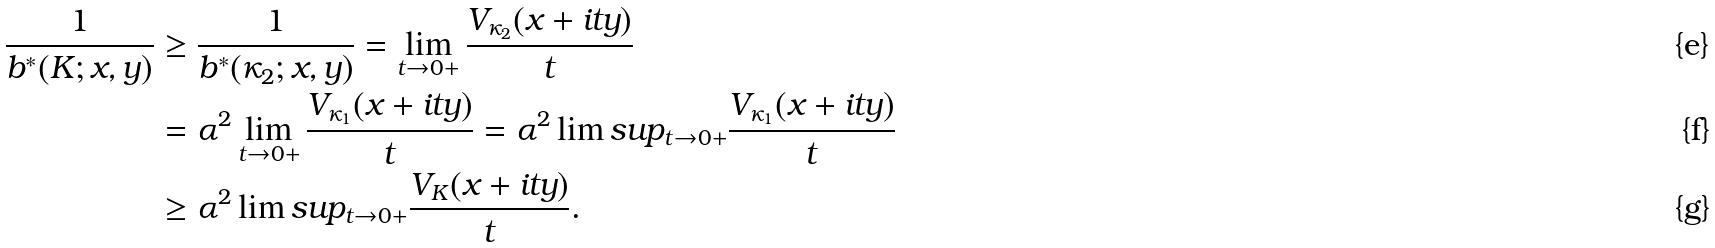Convert formula to latex. <formula><loc_0><loc_0><loc_500><loc_500>\frac { 1 } { b ^ { * } ( K ; x , y ) } & \geq \frac { 1 } { b ^ { * } ( \kappa _ { 2 } ; x , y ) } = \lim _ { t \to 0 + } \frac { V _ { \kappa _ { 2 } } ( x + i t y ) } { t } \\ & = { \alpha ^ { 2 } } \lim _ { t \to 0 + } \frac { V _ { \kappa _ { 1 } } ( x + i t y ) } { t } = { \alpha ^ { 2 } } \lim s u p _ { t \to 0 + } \frac { V _ { \kappa _ { 1 } } ( x + i t y ) } { t } \\ & \geq { \alpha ^ { 2 } } \lim s u p _ { t \to 0 + } \frac { V _ { K } ( x + i t y ) } { t } .</formula> 